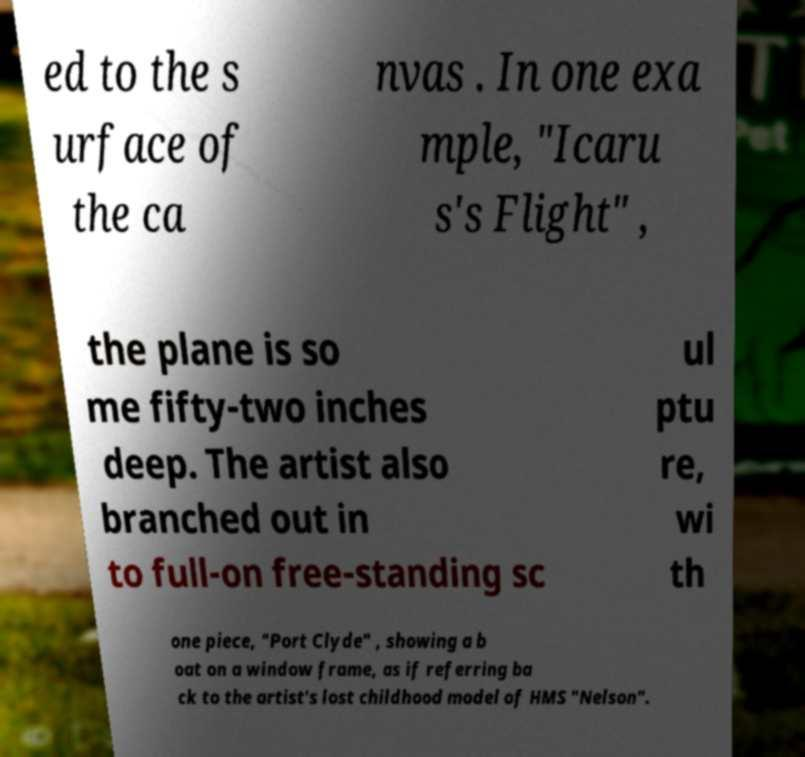Can you accurately transcribe the text from the provided image for me? ed to the s urface of the ca nvas . In one exa mple, "Icaru s's Flight" , the plane is so me fifty-two inches deep. The artist also branched out in to full-on free-standing sc ul ptu re, wi th one piece, "Port Clyde" , showing a b oat on a window frame, as if referring ba ck to the artist's lost childhood model of HMS "Nelson". 